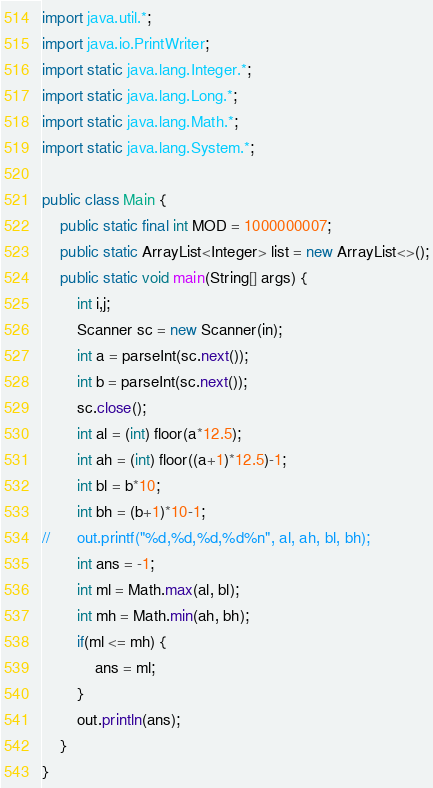Convert code to text. <code><loc_0><loc_0><loc_500><loc_500><_Java_>import java.util.*;
import java.io.PrintWriter;
import static java.lang.Integer.*;
import static java.lang.Long.*;
import static java.lang.Math.*;
import static java.lang.System.*;

public class Main {
	public static final int MOD = 1000000007;
	public static ArrayList<Integer> list = new ArrayList<>();
	public static void main(String[] args) {
		int i,j;
		Scanner sc = new Scanner(in);
		int a = parseInt(sc.next());
		int b = parseInt(sc.next());
		sc.close();
		int al = (int) floor(a*12.5);
		int ah = (int) floor((a+1)*12.5)-1;
		int bl = b*10;
		int bh = (b+1)*10-1;
//		out.printf("%d,%d,%d,%d%n", al, ah, bl, bh);
		int ans = -1;
		int ml = Math.max(al, bl);
		int mh = Math.min(ah, bh);
		if(ml <= mh) {
			ans = ml;
		}
		out.println(ans);
	}
}
</code> 